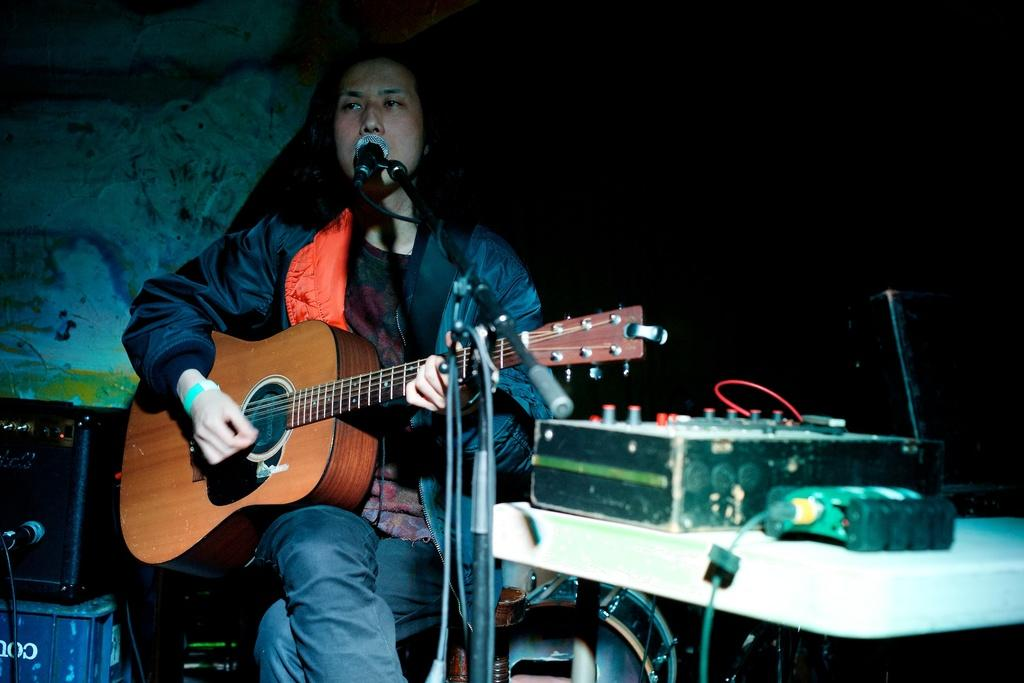Who is the main subject in the image? There is a man in the image. What is the man doing in the image? The man is sitting in the image. What object is the man holding? The man is holding a guitar in the image. What is the purpose of the microphone in front of the man? The microphone is likely used for amplifying the man's voice or guitar playing. How much does the line weigh in the image? There is no line present in the image, so it is not possible to determine its weight. 